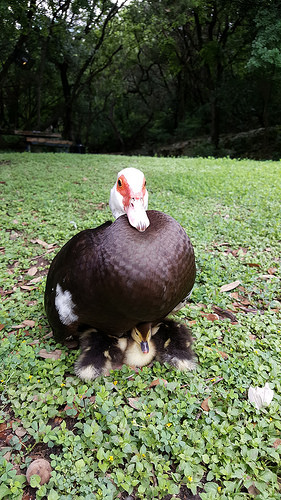<image>
Is the duck in front of the duckling? No. The duck is not in front of the duckling. The spatial positioning shows a different relationship between these objects. 